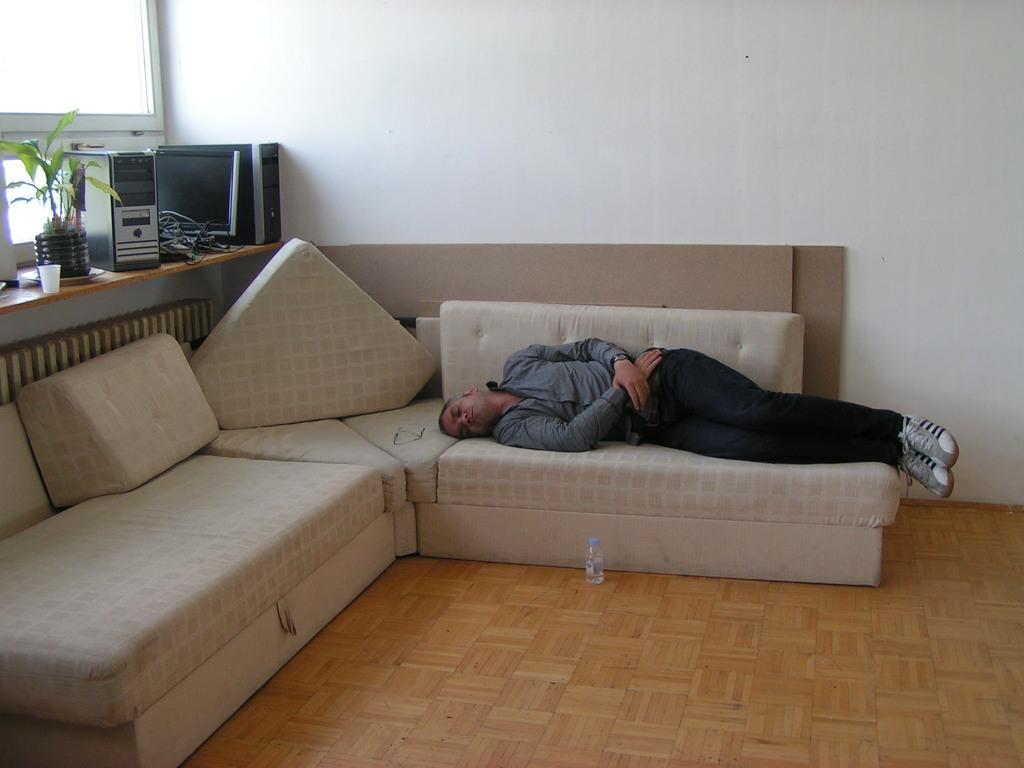Please provide a concise description of this image. In this image there is a person sleeping on the couch wearing shoes and at the bottom there is a water bottle on the floor and at the left side of the image there are C. P. U's and plant. 